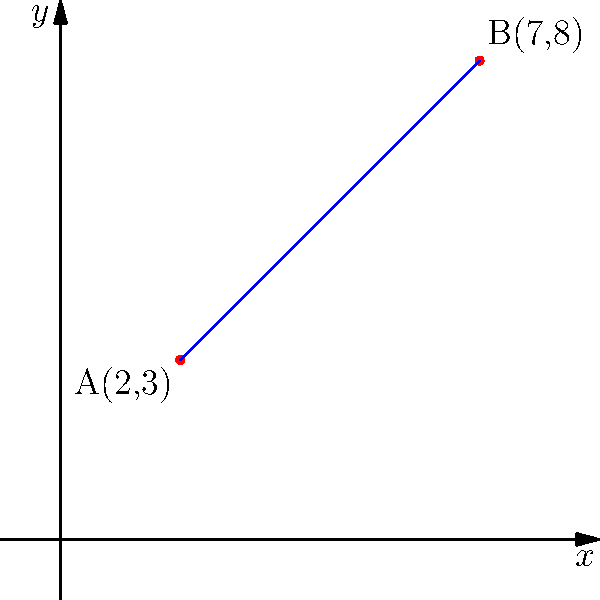Two foreign volunteers need to travel between two villages in your community. Their locations are represented on a map using a coordinate system, with Village A at point (2,3) and Village B at point (7,8). As a local guide, you need to help them determine the straight-line distance between these villages. Using the distance formula, calculate the distance between points A and B. To find the distance between two points on a coordinate plane, we use the distance formula:

$$ d = \sqrt{(x_2-x_1)^2 + (y_2-y_1)^2} $$

Where $(x_1,y_1)$ are the coordinates of the first point and $(x_2,y_2)$ are the coordinates of the second point.

Given:
Point A: $(x_1,y_1) = (2,3)$
Point B: $(x_2,y_2) = (7,8)$

Step 1: Substitute the values into the formula:
$$ d = \sqrt{(7-2)^2 + (8-3)^2} $$

Step 2: Simplify inside the parentheses:
$$ d = \sqrt{5^2 + 5^2} $$

Step 3: Calculate the squares:
$$ d = \sqrt{25 + 25} $$

Step 4: Add inside the square root:
$$ d = \sqrt{50} $$

Step 5: Simplify the square root:
$$ d = 5\sqrt{2} $$

Therefore, the distance between Village A and Village B is $5\sqrt{2}$ units.
Answer: $5\sqrt{2}$ units 